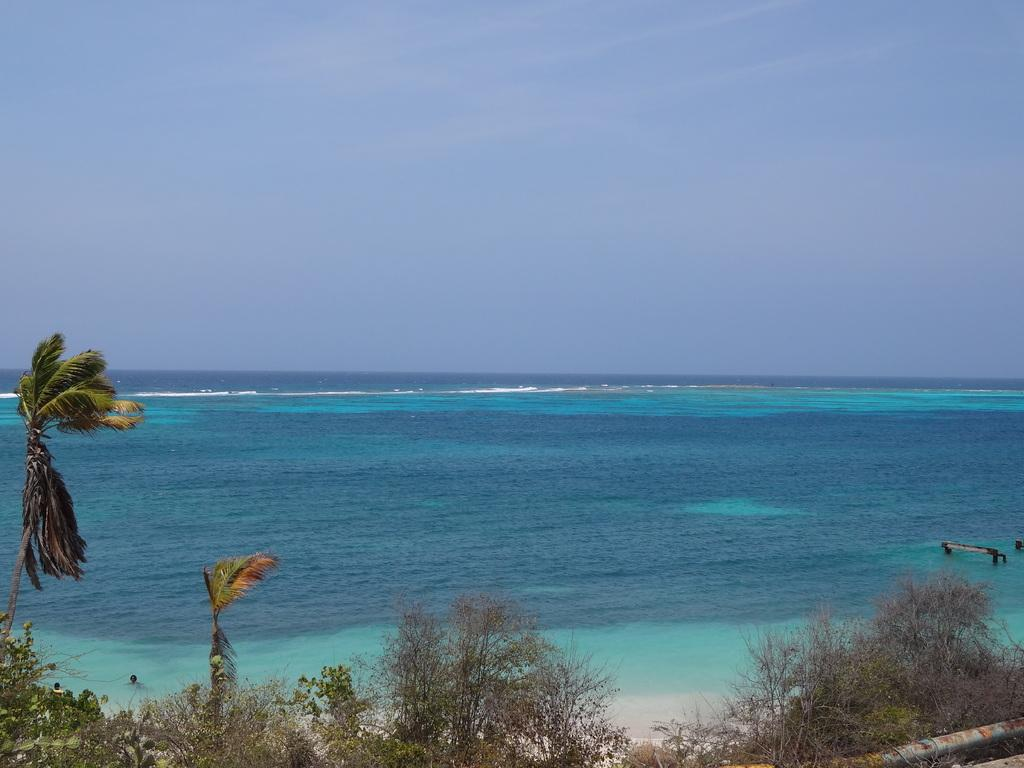What is the main feature in the center of the image? There is a sea in the center of the image. What type of vegetation can be seen at the bottom of the image? There are trees at the bottom of the image. What part of the natural environment is visible in the background of the image? The sky is visible in the background of the image. How many horses can be seen grazing near the trees in the image? There are no horses present in the image; it features a sea, trees, and a sky. What type of bit is used by the brain in the image? There is no bit or brain present in the image. 